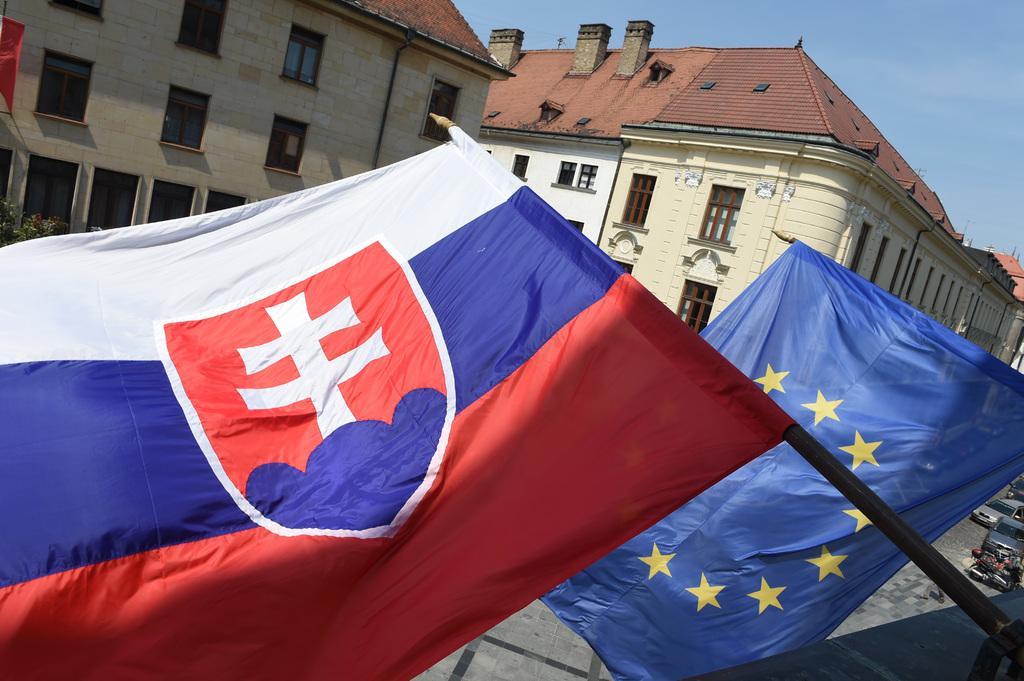Could you give a brief overview of what you see in this image? In this image we can see flags. In the background, we can see the buildings. At the top of the image, we can see the sky. We can see vehicles and pavement on the right side of the image. 